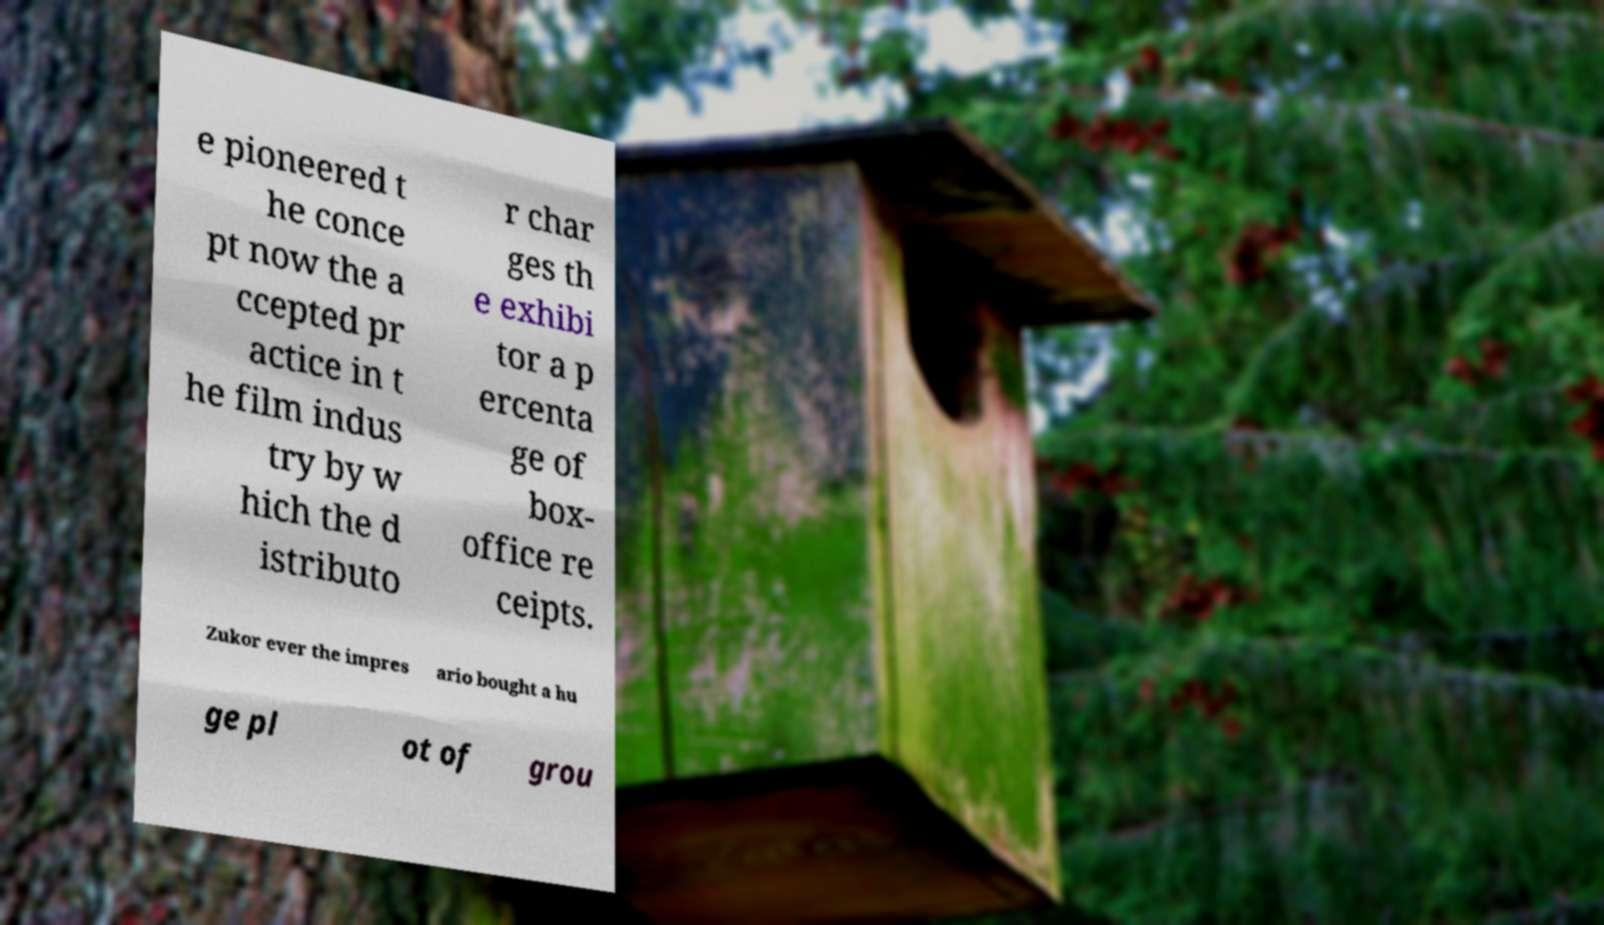For documentation purposes, I need the text within this image transcribed. Could you provide that? e pioneered t he conce pt now the a ccepted pr actice in t he film indus try by w hich the d istributo r char ges th e exhibi tor a p ercenta ge of box- office re ceipts. Zukor ever the impres ario bought a hu ge pl ot of grou 